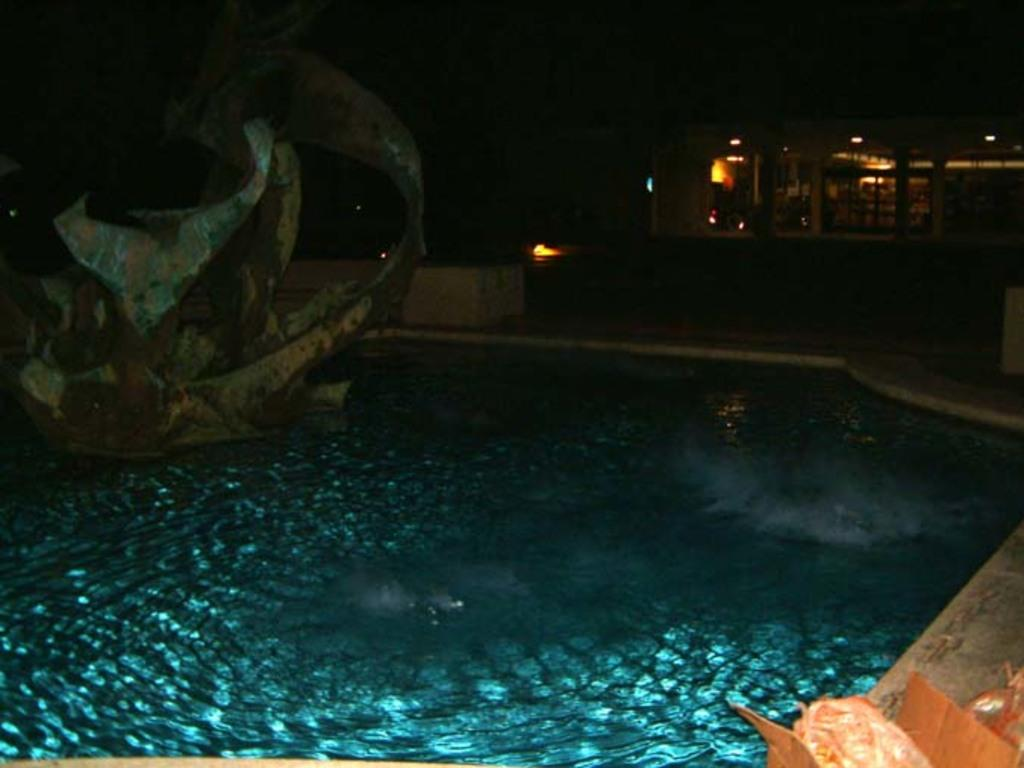What is the main subject in the image? There is a structure in the image. What is located near the structure? There is a pool in the image. What can be seen in the distance behind the structure? There is a building in the background of the image. Can you describe the object in the right bottom of the image? Unfortunately, the provided facts do not give enough information to describe the object in the right bottom of the image. Where is the fireman located in the image? There is no fireman present in the image. What type of kettle is visible in the image? There is no kettle present in the image. 